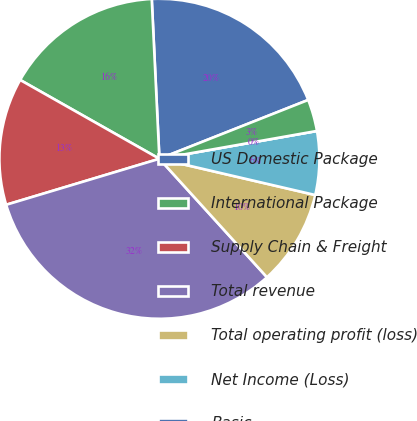<chart> <loc_0><loc_0><loc_500><loc_500><pie_chart><fcel>US Domestic Package<fcel>International Package<fcel>Supply Chain & Freight<fcel>Total revenue<fcel>Total operating profit (loss)<fcel>Net Income (Loss)<fcel>Basic<fcel>Diluted<nl><fcel>19.77%<fcel>16.04%<fcel>12.84%<fcel>32.09%<fcel>9.63%<fcel>6.42%<fcel>0.0%<fcel>3.21%<nl></chart> 